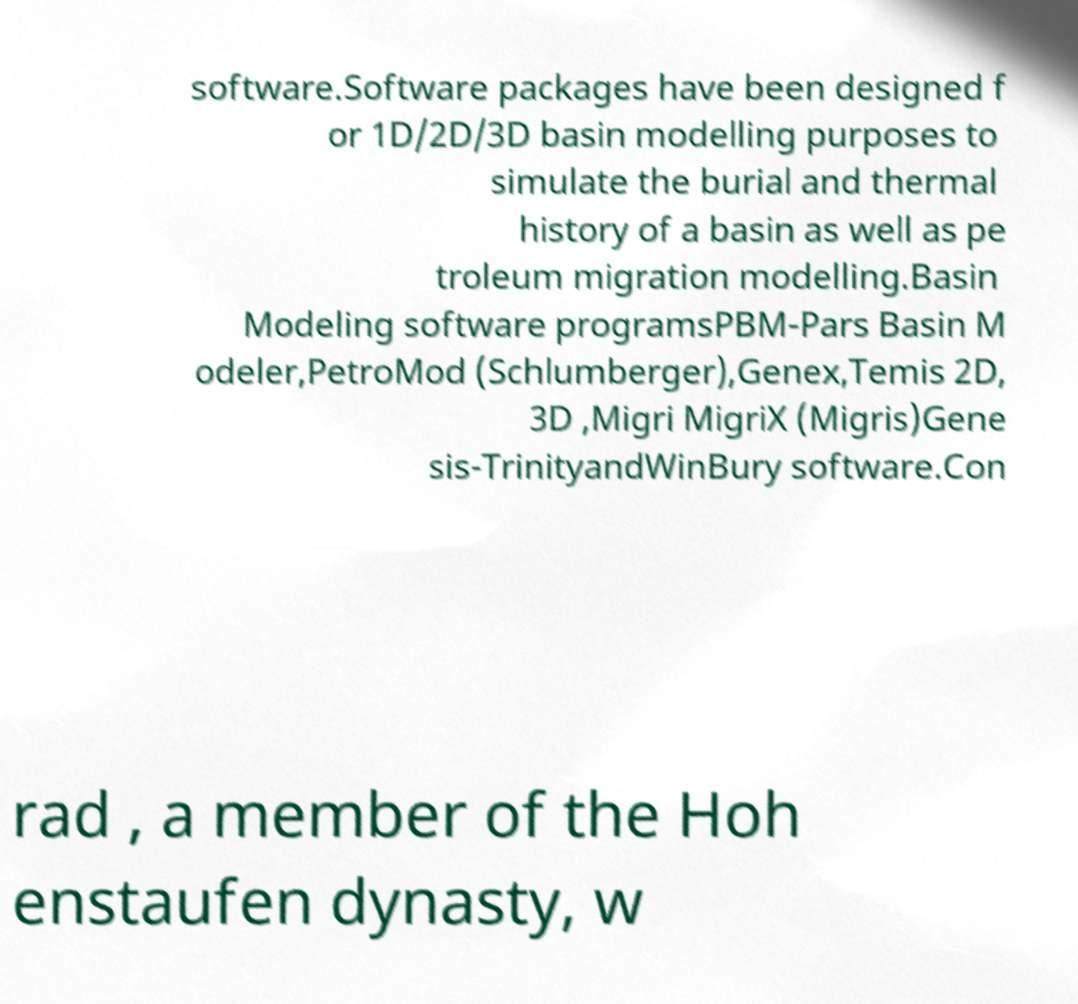I need the written content from this picture converted into text. Can you do that? software.Software packages have been designed f or 1D/2D/3D basin modelling purposes to simulate the burial and thermal history of a basin as well as pe troleum migration modelling.Basin Modeling software programsPBM-Pars Basin M odeler,PetroMod (Schlumberger),Genex,Temis 2D, 3D ,Migri MigriX (Migris)Gene sis-TrinityandWinBury software.Con rad , a member of the Hoh enstaufen dynasty, w 